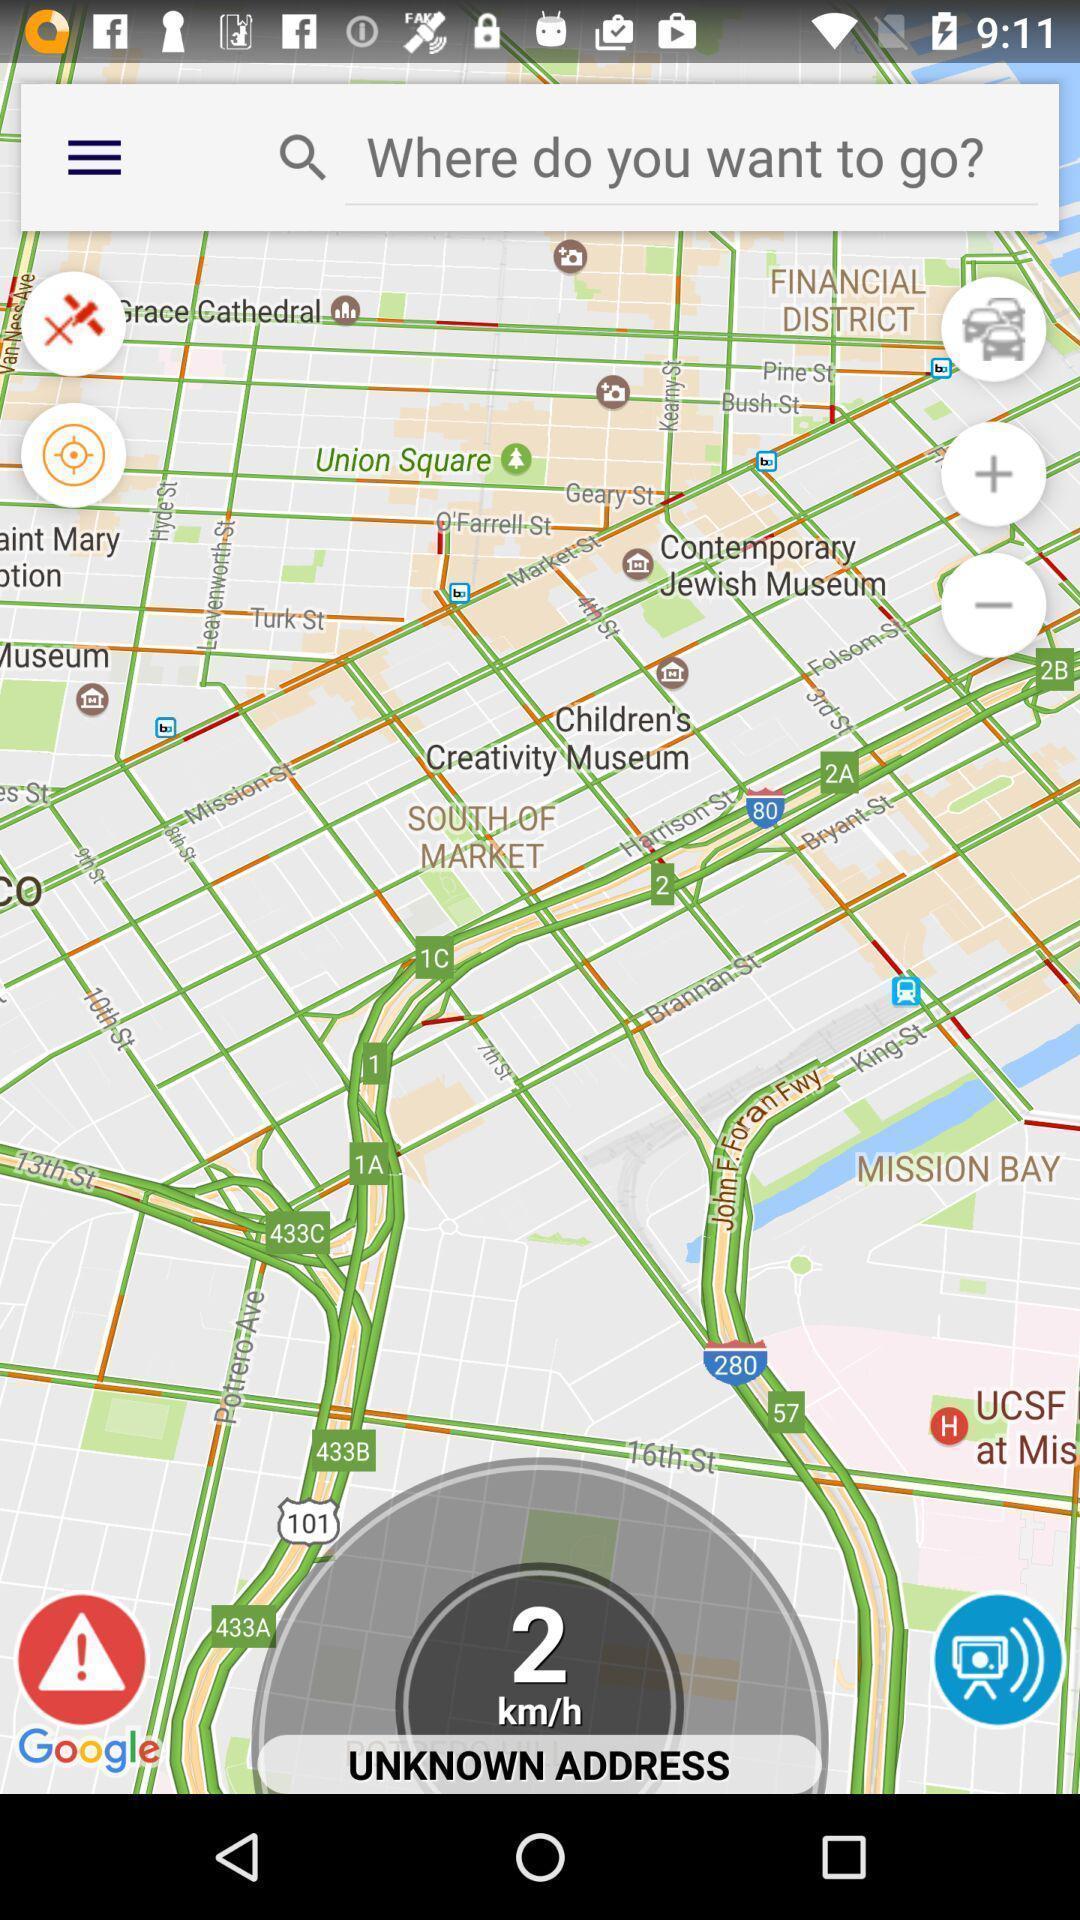What is the overall content of this screenshot? Screen shows car navigation. 